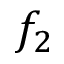Convert formula to latex. <formula><loc_0><loc_0><loc_500><loc_500>f _ { 2 }</formula> 